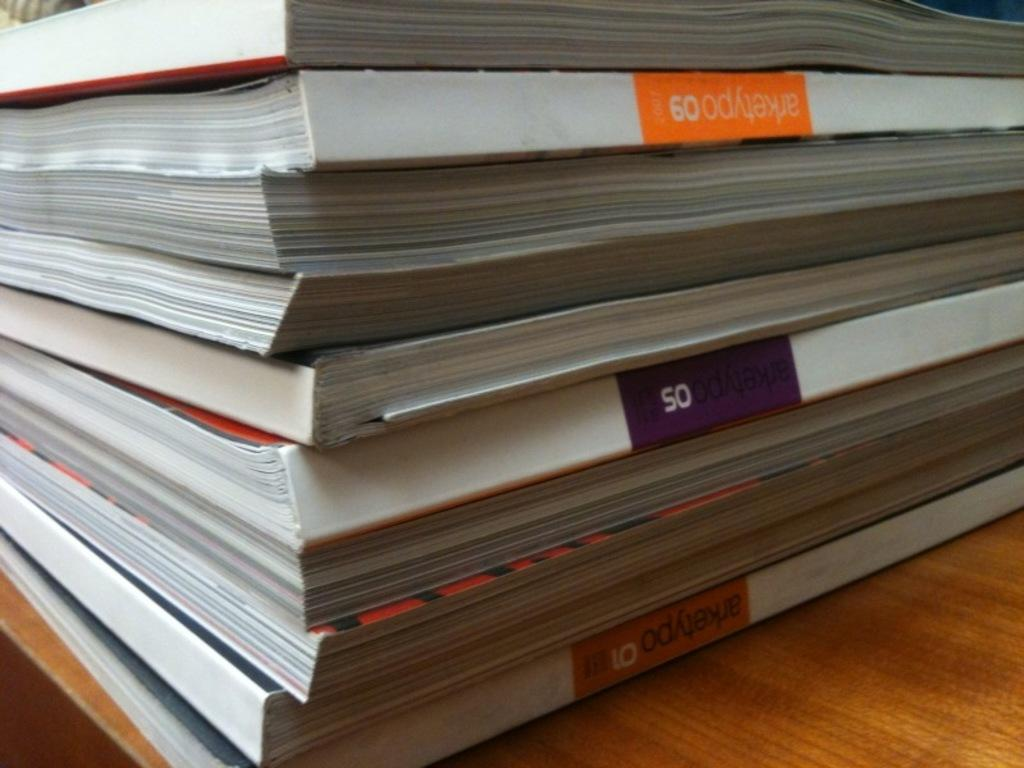<image>
Give a short and clear explanation of the subsequent image. A stack of books that say Arketypo 09. 